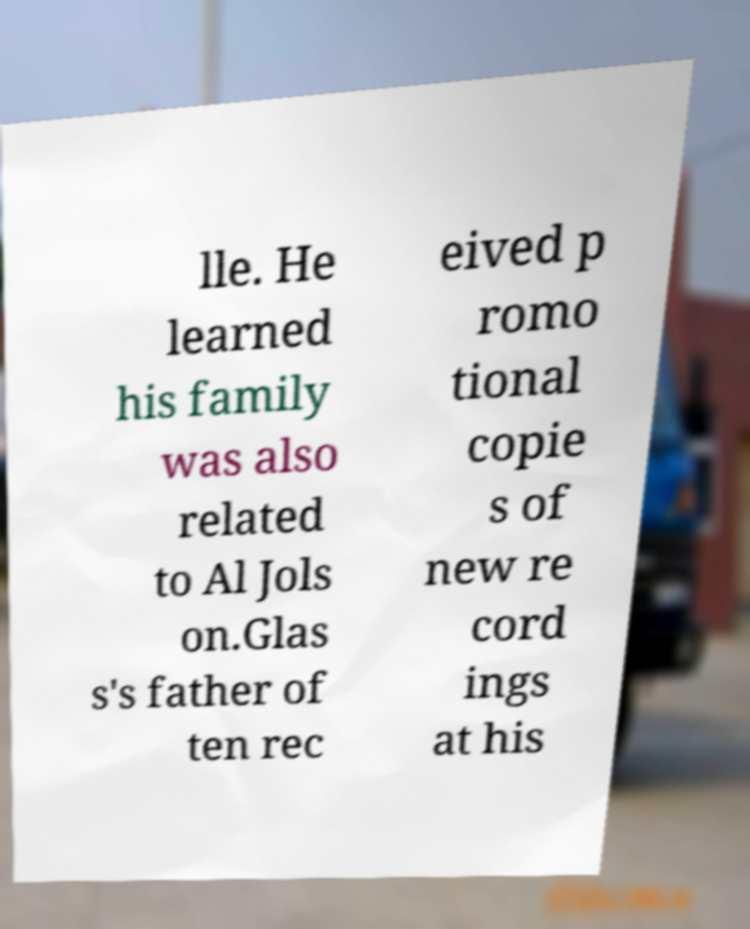Could you extract and type out the text from this image? lle. He learned his family was also related to Al Jols on.Glas s's father of ten rec eived p romo tional copie s of new re cord ings at his 